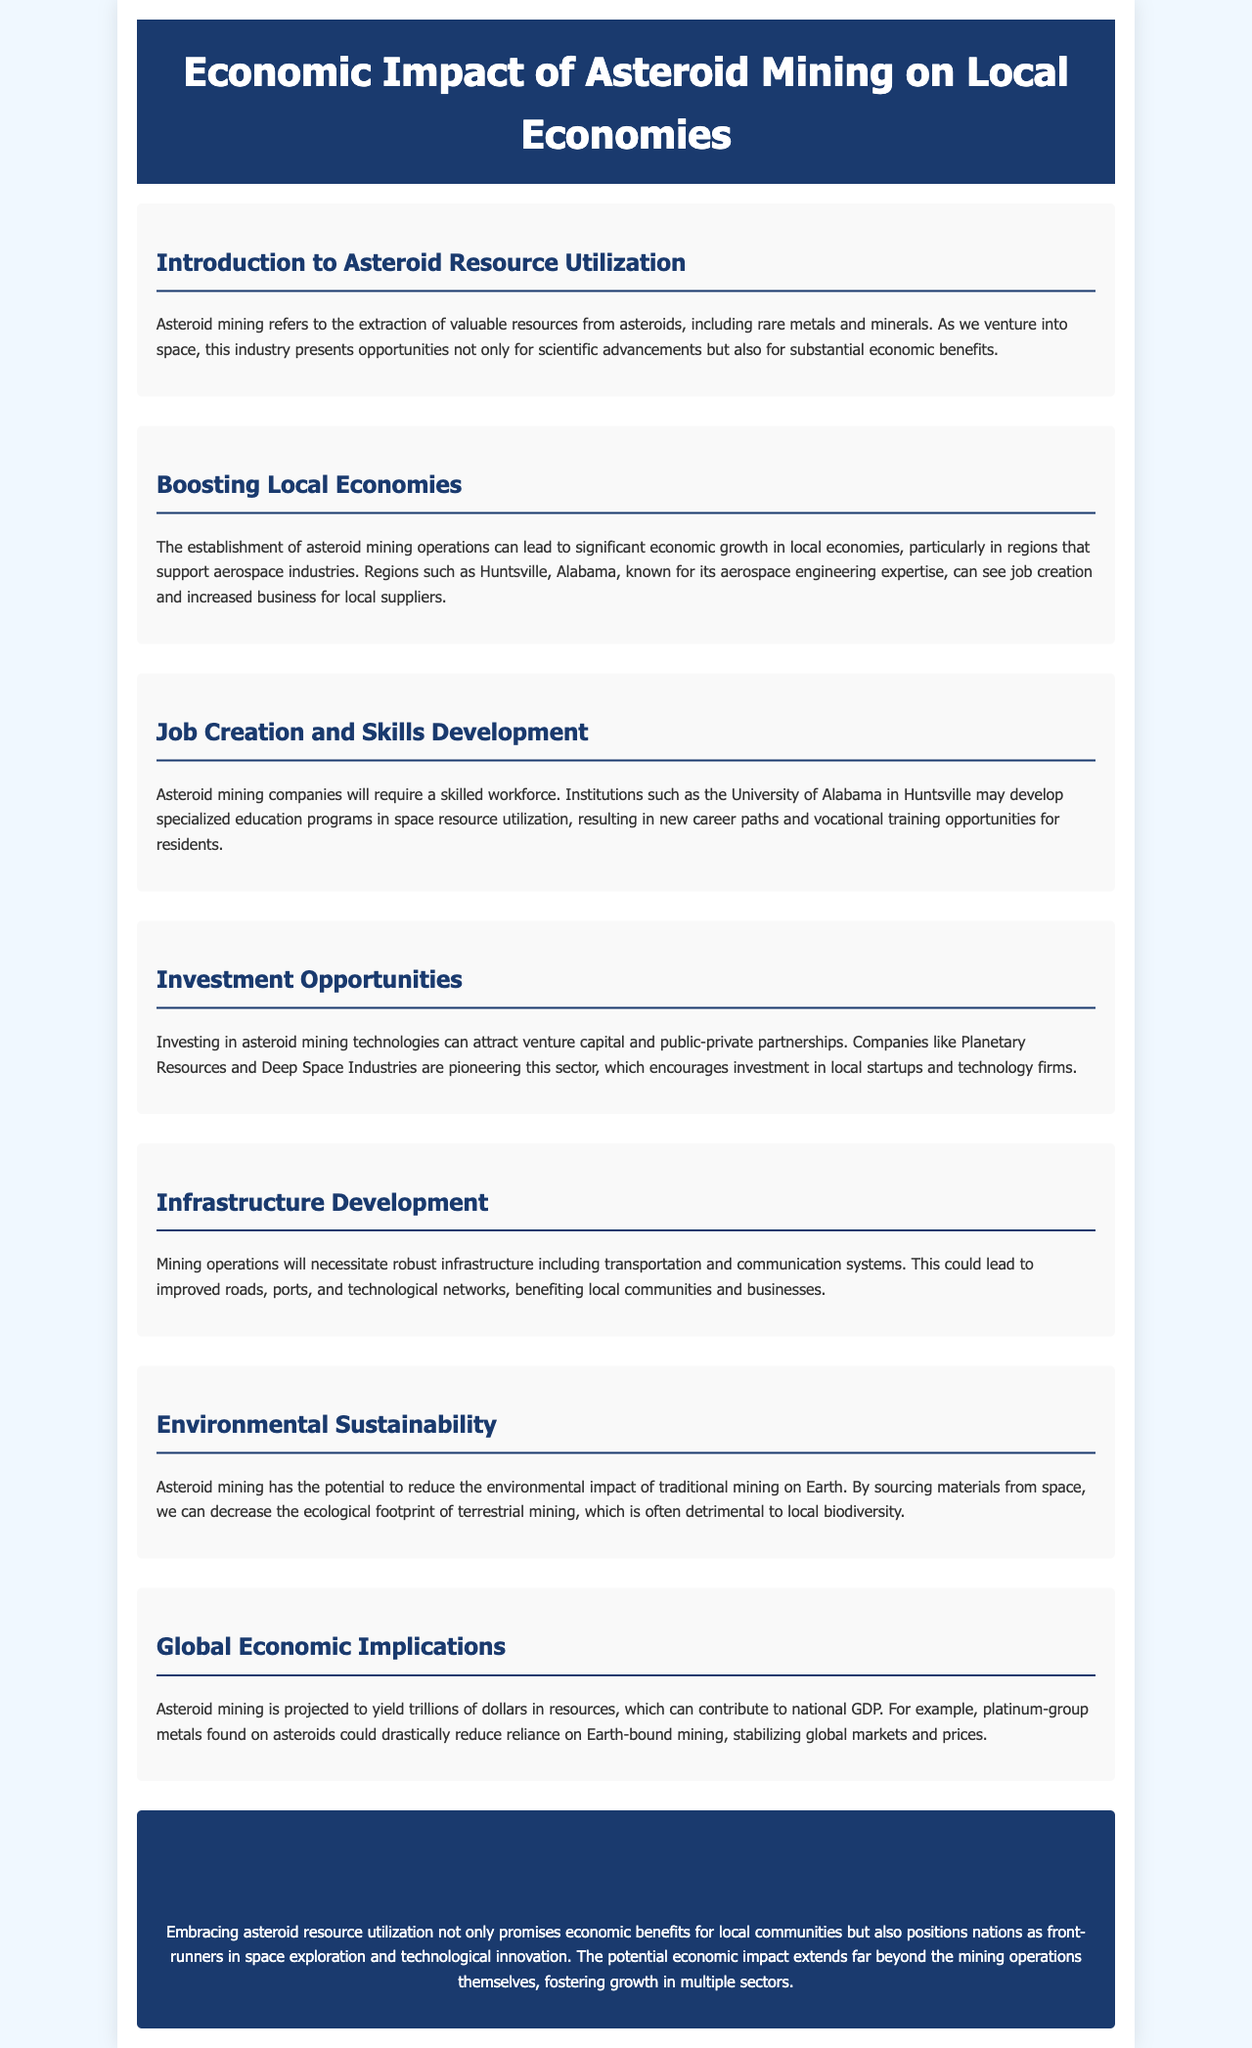What is asteroid mining? Asteroid mining refers to the extraction of valuable resources from asteroids, including rare metals and minerals.
Answer: Extraction of valuable resources from asteroids Where can significant economic growth from asteroid mining be seen? The document mentions regions that support aerospace industries, particularly Huntsville, Alabama.
Answer: Huntsville, Alabama What educational opportunities may arise due to asteroid mining? Specialized education programs in space resource utilization will be developed, creating new career paths.
Answer: New career paths Which companies are mentioned as pioneers in the asteroid mining sector? The document names Planetary Resources and Deep Space Industries as pioneering companies.
Answer: Planetary Resources and Deep Space Industries What type of infrastructure development is necessary for mining operations? Mining operations will require robust transportation and communication systems, including improved roads and ports.
Answer: Transportation and communication systems What is projected to be the economic yield from asteroid mining? The document states that asteroid mining is projected to yield trillions of dollars in resources.
Answer: Trillions of dollars How can asteroid mining contribute to environmental sustainability? By sourcing materials from space, asteroid mining can decrease the ecological footprint of terrestrial mining.
Answer: Decrease ecological footprint What is the conclusion about the economic benefits of asteroid resource utilization? The conclusion highlights that asteroid resource utilization promises economic benefits for local communities and fosters growth in multiple sectors.
Answer: Economic benefits for local communities 